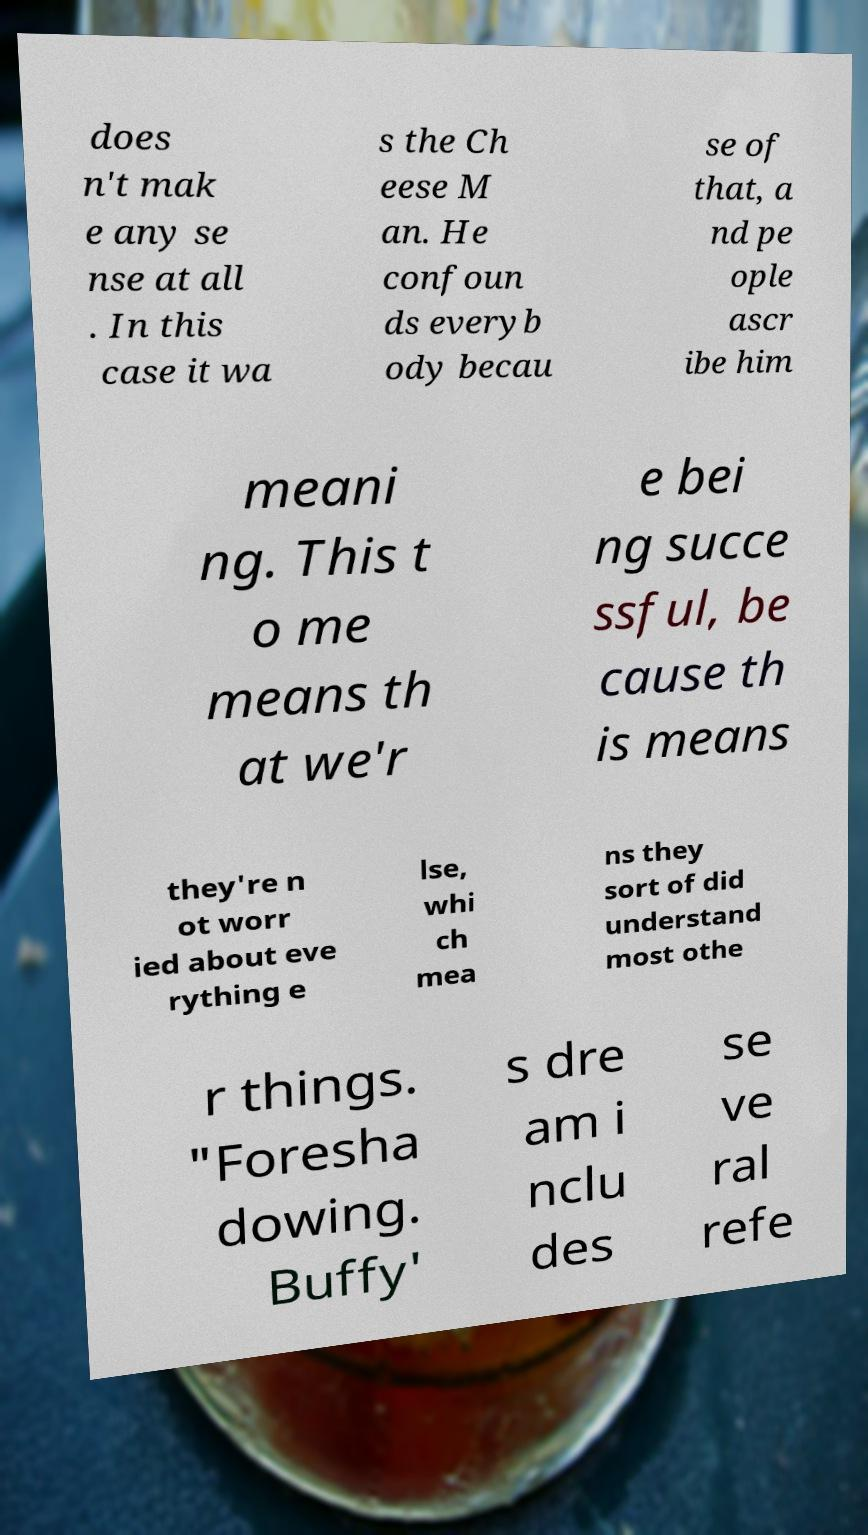Could you assist in decoding the text presented in this image and type it out clearly? does n't mak e any se nse at all . In this case it wa s the Ch eese M an. He confoun ds everyb ody becau se of that, a nd pe ople ascr ibe him meani ng. This t o me means th at we'r e bei ng succe ssful, be cause th is means they're n ot worr ied about eve rything e lse, whi ch mea ns they sort of did understand most othe r things. "Foresha dowing. Buffy' s dre am i nclu des se ve ral refe 